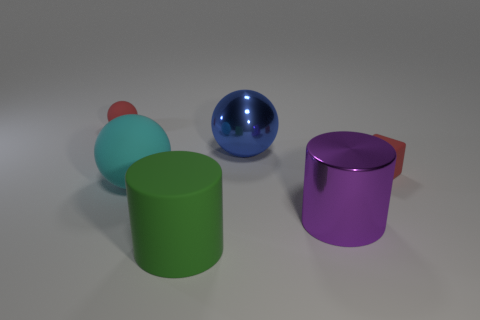Subtract all blue spheres. How many spheres are left? 2 Subtract all purple cylinders. How many cylinders are left? 1 Subtract 2 balls. How many balls are left? 1 Subtract all cyan cylinders. Subtract all cyan cubes. How many cylinders are left? 2 Subtract all green balls. How many green cylinders are left? 1 Add 3 red metal cubes. How many objects exist? 9 Subtract 1 green cylinders. How many objects are left? 5 Subtract all cylinders. How many objects are left? 4 Subtract all big cyan things. Subtract all tiny matte objects. How many objects are left? 3 Add 6 big blue objects. How many big blue objects are left? 7 